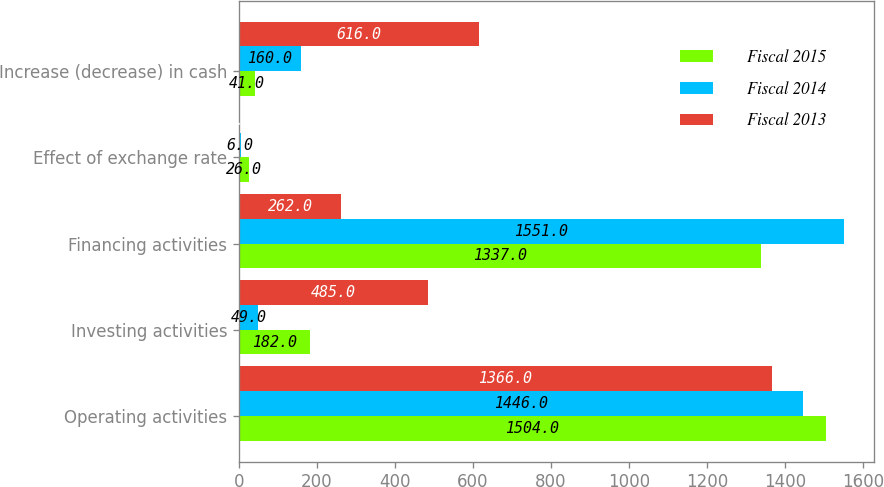Convert chart to OTSL. <chart><loc_0><loc_0><loc_500><loc_500><stacked_bar_chart><ecel><fcel>Operating activities<fcel>Investing activities<fcel>Financing activities<fcel>Effect of exchange rate<fcel>Increase (decrease) in cash<nl><fcel>Fiscal 2015<fcel>1504<fcel>182<fcel>1337<fcel>26<fcel>41<nl><fcel>Fiscal 2014<fcel>1446<fcel>49<fcel>1551<fcel>6<fcel>160<nl><fcel>Fiscal 2013<fcel>1366<fcel>485<fcel>262<fcel>3<fcel>616<nl></chart> 